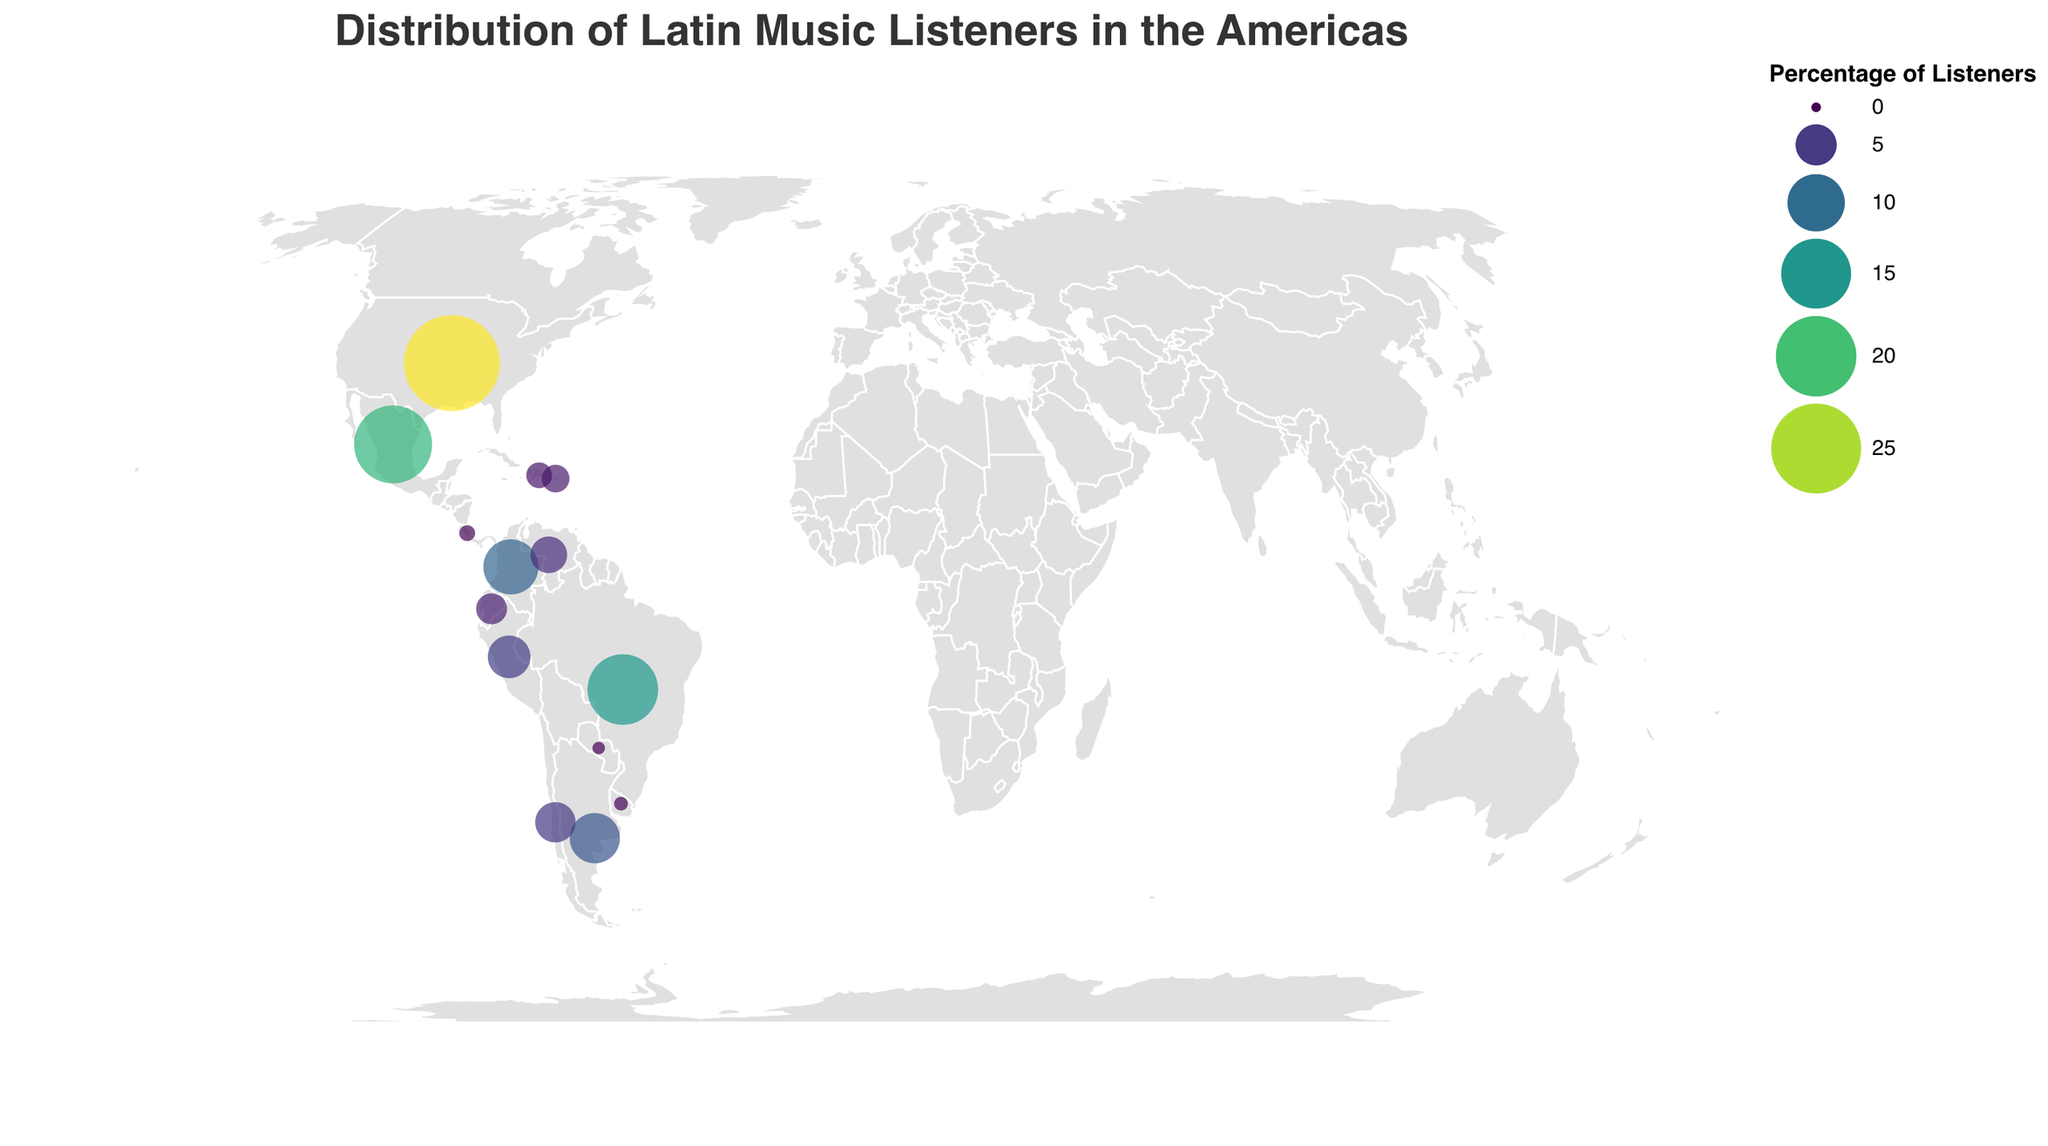What's the title of the figure? The title of the figure is shown at the top. It reads, "Distribution of Latin Music Listeners in the Americas."
Answer: Distribution of Latin Music Listeners in the Americas How many countries are represented in this figure? Each country is represented as a data point on the map. Counting these points, there are 14 countries.
Answer: 14 Which country has the highest percentage of Latin music listeners? By examining the sizes and colors of the circles (or by consulting the legend), the United States has the largest circle and the deepest color, indicating it has the highest percentage at 28.5%.
Answer: United States Which country has the smallest percentage of Latin music listeners? The smallest circle, with the lightest color, represents Paraguay, with a percentage of 0.2%.
Answer: Paraguay What is the combined percentage of Latin music listeners in Brazil, Colombia, and Argentina? Summing the percentages for Brazil (15.3%), Colombia (9.2%), and Argentina (7.6%): 15.3 + 9.2 + 7.6 = 32.1%
Answer: 32.1% How does the percentage of listeners in Chile compare to that of Venezuela? Looking at the sizes and colors of the circles, Chile has 4.8% and Venezuela has 3.9%. Therefore, Chile has a higher percentage of listeners than Venezuela.
Answer: Chile has a higher percentage Which countries have a percentage of listeners below 1%? By reviewing the legend and the data points, Costa Rica (0.5%), Uruguay (0.3%), and Paraguay (0.2%) all have percentages below 1%.
Answer: Costa Rica, Uruguay, Paraguay What is the average percentage of listeners in Mexico, Colombia, and Argentina? Sum the percentages and divide by the number of countries: (18.7 + 9.2 + 7.6) / 3 = 35.5 / 3 = 11.83%
Answer: 11.83% What color scheme is used to represent the percentage of listeners? The legend indicates that a 'viridis' color scheme is used, with colors ranging from lighter to darker shades as the percentage increases.
Answer: viridis Which country in South America, excluding Brazil, has the highest percentage of listeners? Excluding Brazil, the South American country with the highest percentage is Colombia, with 9.2%.
Answer: Colombia 